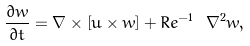<formula> <loc_0><loc_0><loc_500><loc_500>\frac { \partial { w } } { \partial t } = \nabla \times \left [ { u } \times { w } \right ] + R e ^ { - 1 } \ \nabla ^ { 2 } { w } ,</formula> 